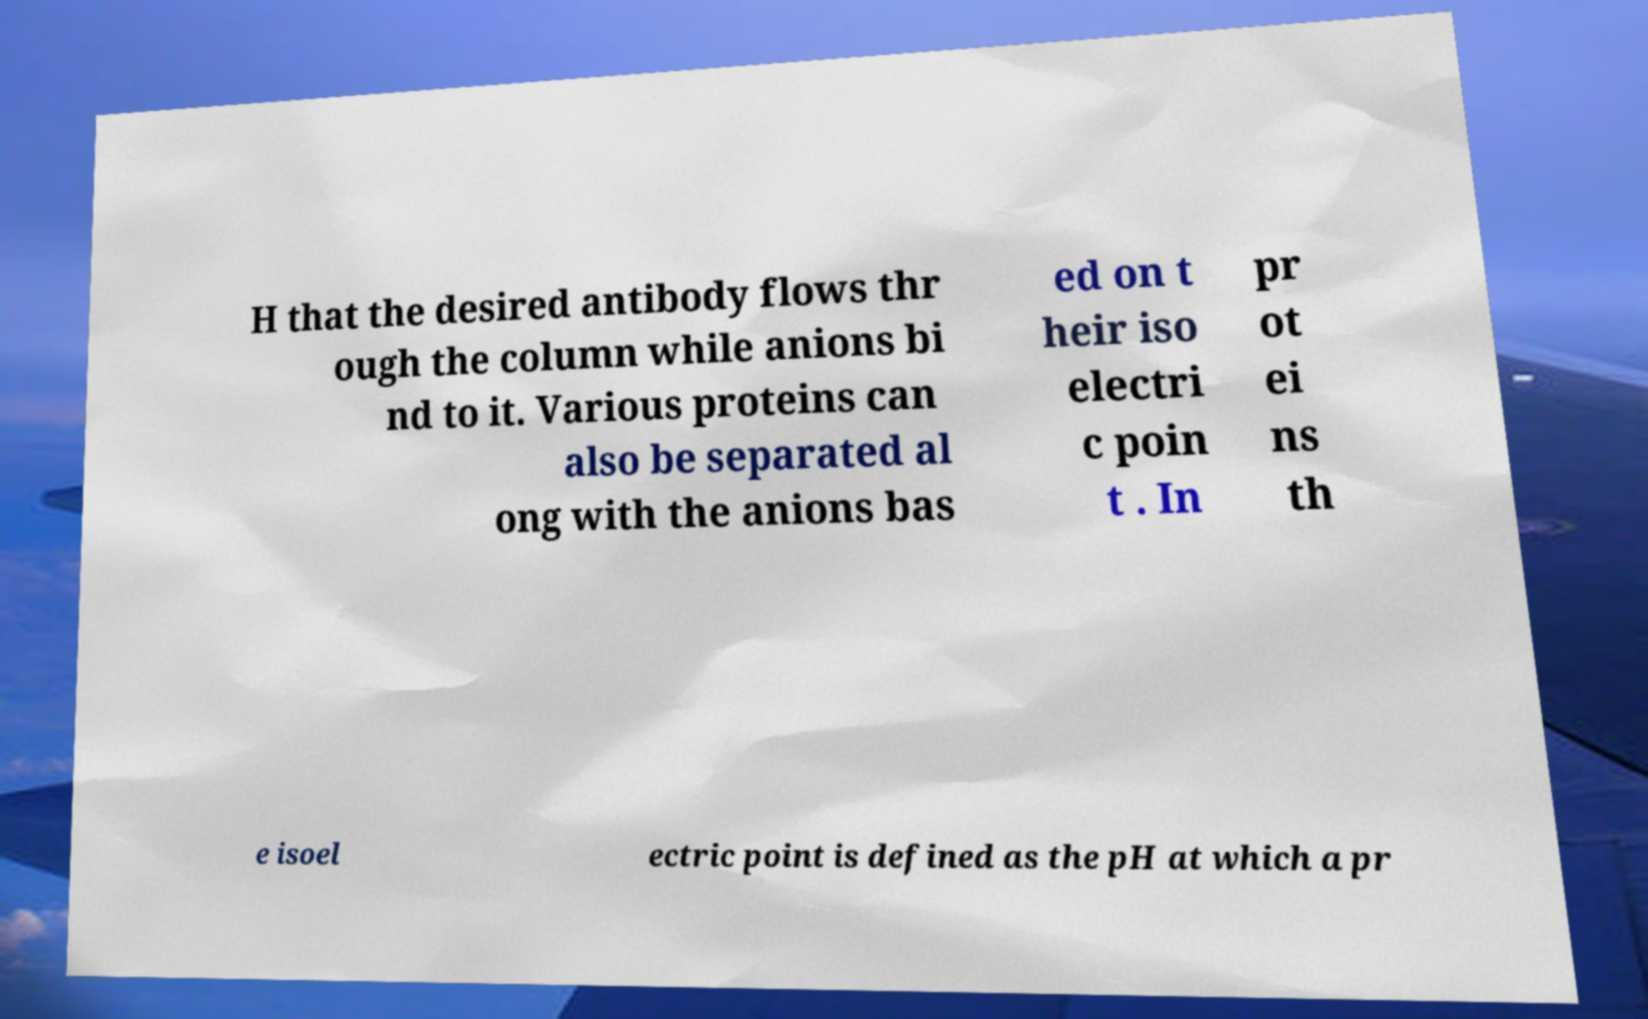Can you read and provide the text displayed in the image?This photo seems to have some interesting text. Can you extract and type it out for me? H that the desired antibody flows thr ough the column while anions bi nd to it. Various proteins can also be separated al ong with the anions bas ed on t heir iso electri c poin t . In pr ot ei ns th e isoel ectric point is defined as the pH at which a pr 